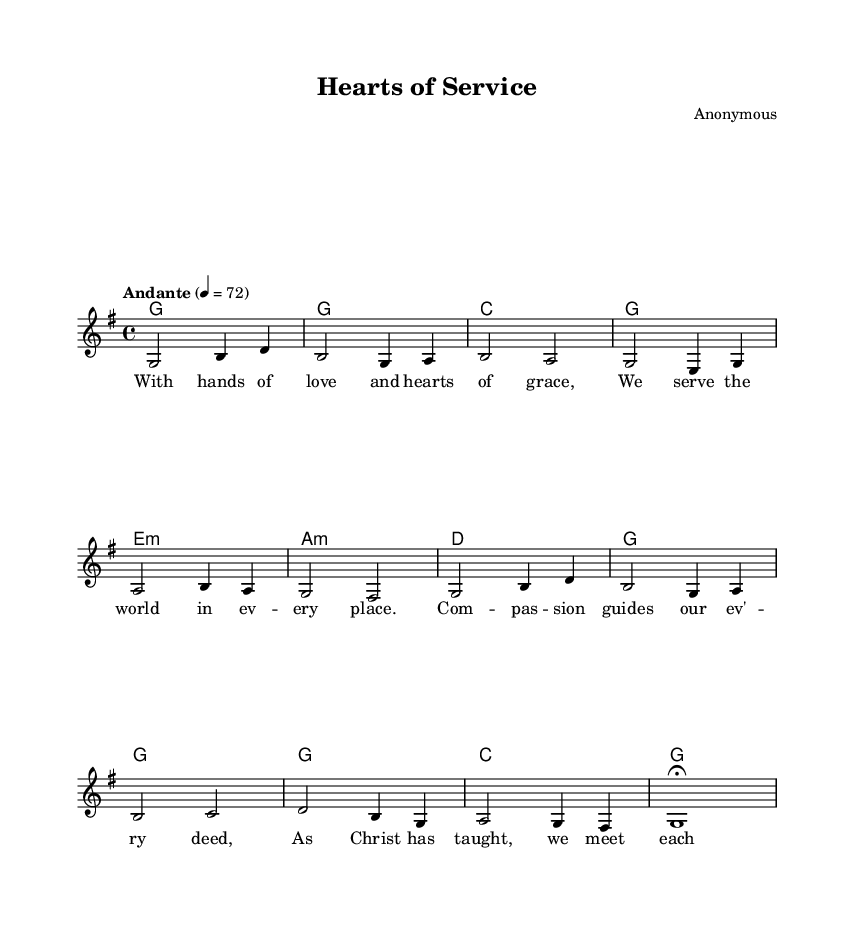What is the key signature of this music? The key signature is G major, which has one sharp (F#).
Answer: G major What is the time signature of this music? The time signature is 4/4, indicating four beats per measure.
Answer: 4/4 What is the tempo marking for this piece? The tempo marking is "Andante," which suggests a moderate pace.
Answer: Andante How many measures are in the melody? The melody consists of 8 measures, as counted from the start to the end of the given notes.
Answer: 8 What is the repeating chord progression in the harmonies? The repeating chord progression is G, C, G, E minor, A minor, D, G, which is typical for contemplative music focusing on service themes.
Answer: G, C, G, E minor, A minor, D, G What is the primary theme expressed in the lyrics? The primary theme expressed in the lyrics is compassion and service, emphasizing meeting the needs of others as taught by Christ.
Answer: Compassion and service Which phrase in the lyrics suggests guidance? The phrase "compassion guides" indicates that the action is based on guidance from compassion.
Answer: Compassion guides 